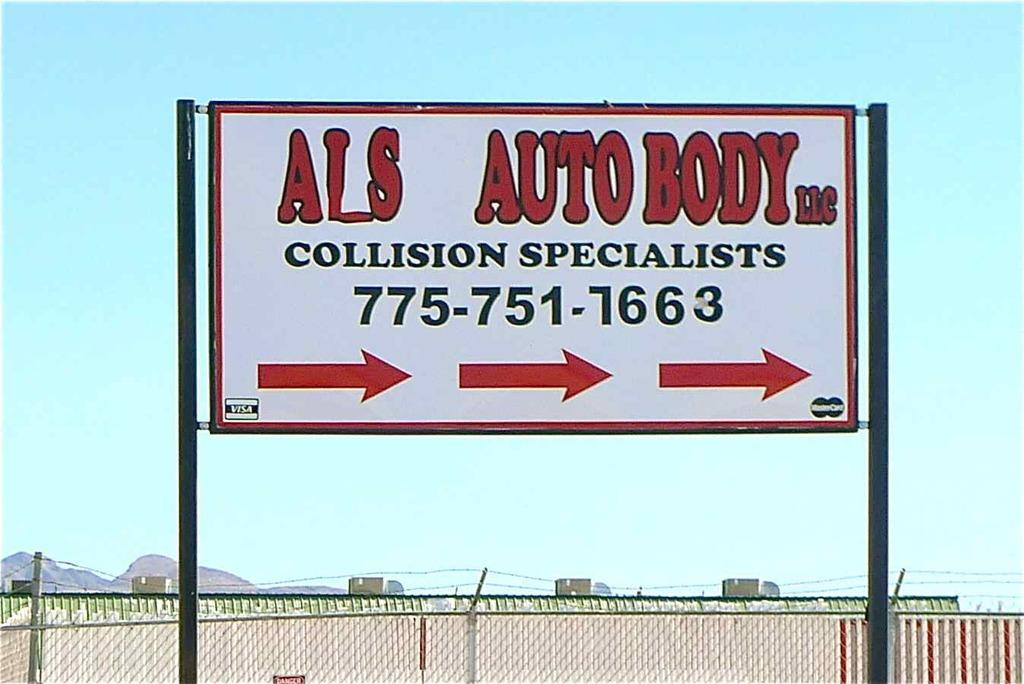<image>
Provide a brief description of the given image. Sign with Als Auto Body in red and Collision specialists in black with telephone number. 